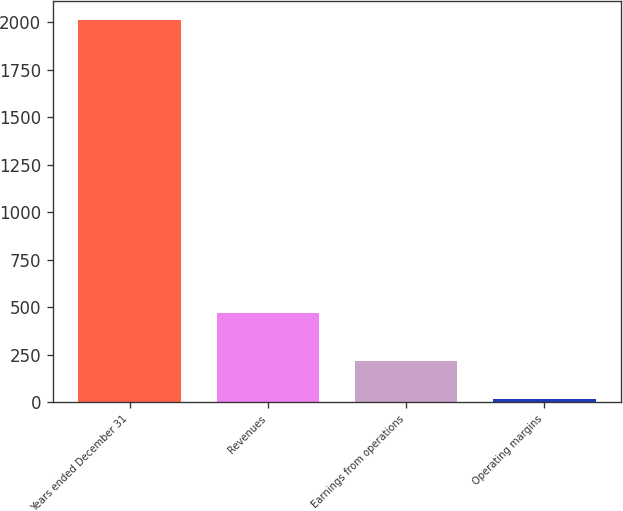<chart> <loc_0><loc_0><loc_500><loc_500><bar_chart><fcel>Years ended December 31<fcel>Revenues<fcel>Earnings from operations<fcel>Operating margins<nl><fcel>2012<fcel>468<fcel>218.3<fcel>19<nl></chart> 